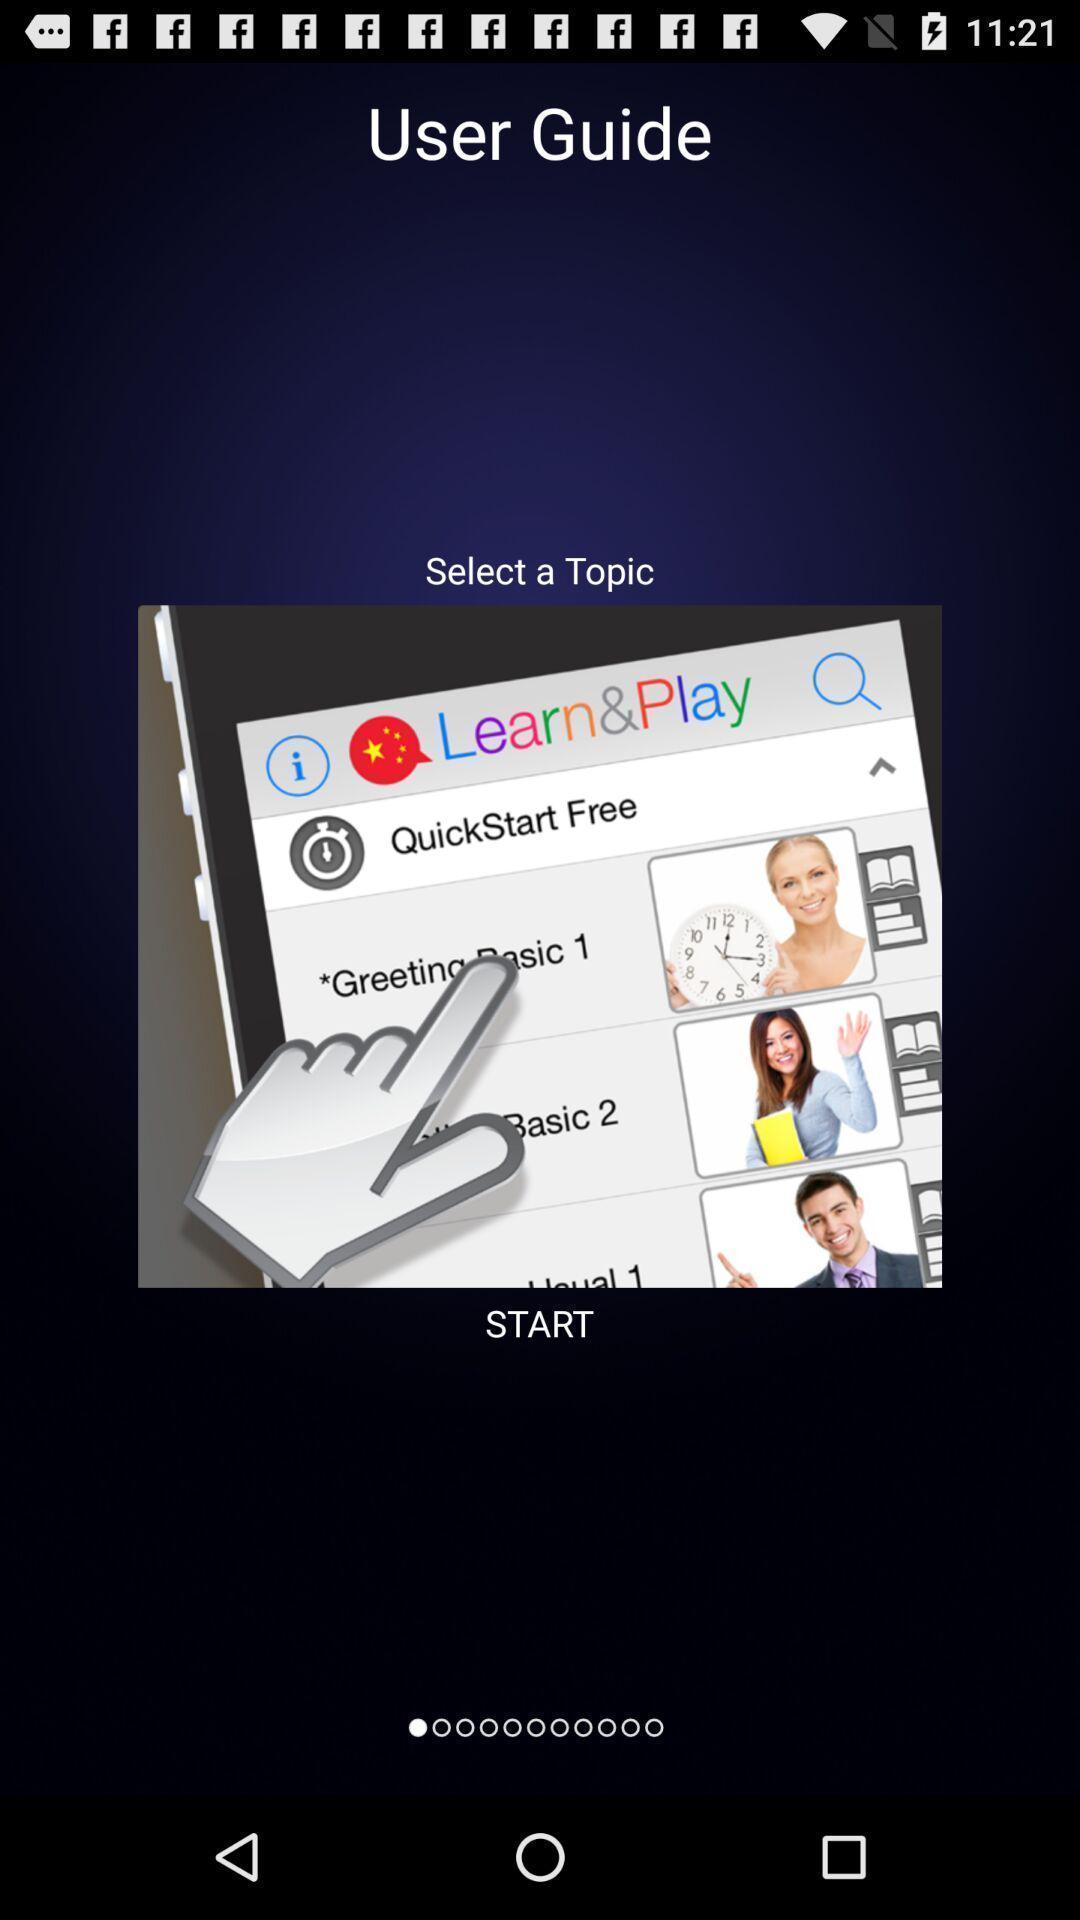What details can you identify in this image? Welcome page or guide for a new application. 